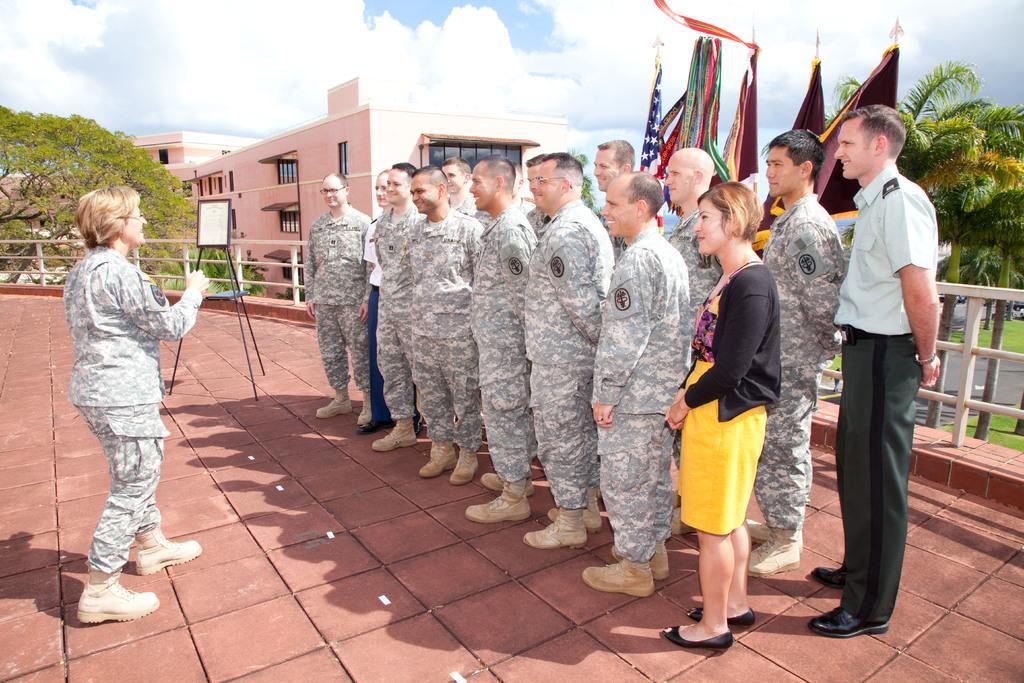Can you describe this image briefly? In this image we can see people standing on the floor and smiling. In the background there are trees, ground, buildings, flags and sky with clouds. 